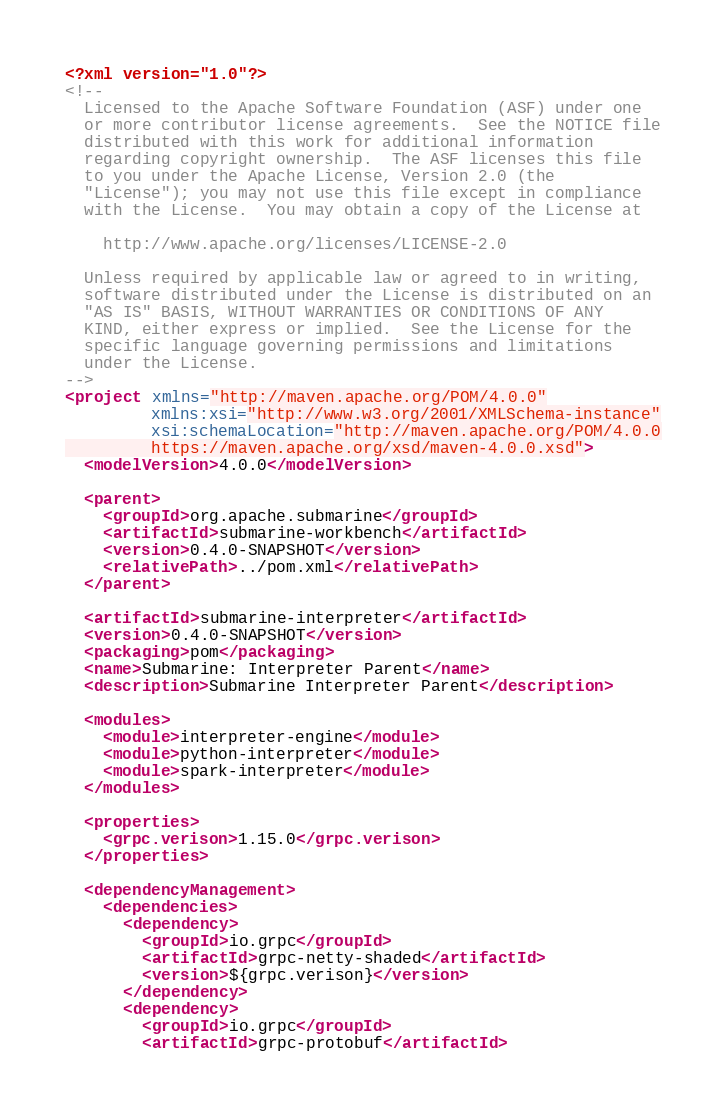<code> <loc_0><loc_0><loc_500><loc_500><_XML_><?xml version="1.0"?>
<!--
  Licensed to the Apache Software Foundation (ASF) under one
  or more contributor license agreements.  See the NOTICE file
  distributed with this work for additional information
  regarding copyright ownership.  The ASF licenses this file
  to you under the Apache License, Version 2.0 (the
  "License"); you may not use this file except in compliance
  with the License.  You may obtain a copy of the License at

    http://www.apache.org/licenses/LICENSE-2.0

  Unless required by applicable law or agreed to in writing,
  software distributed under the License is distributed on an
  "AS IS" BASIS, WITHOUT WARRANTIES OR CONDITIONS OF ANY
  KIND, either express or implied.  See the License for the
  specific language governing permissions and limitations
  under the License.
-->
<project xmlns="http://maven.apache.org/POM/4.0.0"
         xmlns:xsi="http://www.w3.org/2001/XMLSchema-instance"
         xsi:schemaLocation="http://maven.apache.org/POM/4.0.0
         https://maven.apache.org/xsd/maven-4.0.0.xsd">
  <modelVersion>4.0.0</modelVersion>

  <parent>
    <groupId>org.apache.submarine</groupId>
    <artifactId>submarine-workbench</artifactId>
    <version>0.4.0-SNAPSHOT</version>
    <relativePath>../pom.xml</relativePath>
  </parent>

  <artifactId>submarine-interpreter</artifactId>
  <version>0.4.0-SNAPSHOT</version>
  <packaging>pom</packaging>
  <name>Submarine: Interpreter Parent</name>
  <description>Submarine Interpreter Parent</description>

  <modules>
    <module>interpreter-engine</module>
    <module>python-interpreter</module>
    <module>spark-interpreter</module>
  </modules>

  <properties>
    <grpc.verison>1.15.0</grpc.verison>
  </properties>

  <dependencyManagement>
    <dependencies>
      <dependency>
        <groupId>io.grpc</groupId>
        <artifactId>grpc-netty-shaded</artifactId>
        <version>${grpc.verison}</version>
      </dependency>
      <dependency>
        <groupId>io.grpc</groupId>
        <artifactId>grpc-protobuf</artifactId></code> 